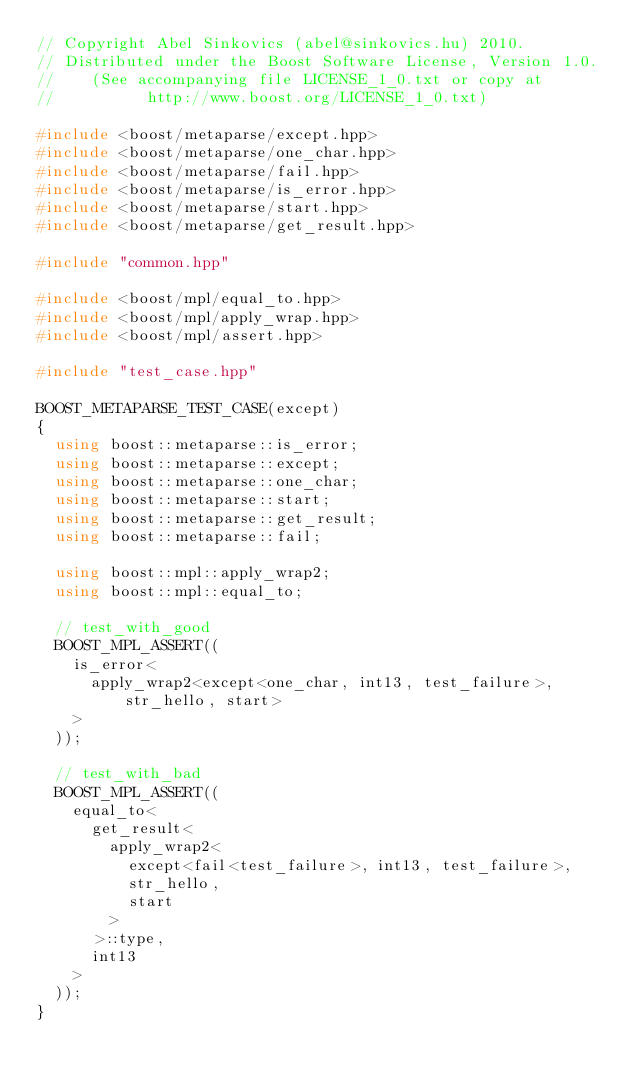Convert code to text. <code><loc_0><loc_0><loc_500><loc_500><_C++_>// Copyright Abel Sinkovics (abel@sinkovics.hu) 2010.
// Distributed under the Boost Software License, Version 1.0.
//    (See accompanying file LICENSE_1_0.txt or copy at
//          http://www.boost.org/LICENSE_1_0.txt)

#include <boost/metaparse/except.hpp>
#include <boost/metaparse/one_char.hpp>
#include <boost/metaparse/fail.hpp>
#include <boost/metaparse/is_error.hpp>
#include <boost/metaparse/start.hpp>
#include <boost/metaparse/get_result.hpp>

#include "common.hpp"

#include <boost/mpl/equal_to.hpp>
#include <boost/mpl/apply_wrap.hpp>
#include <boost/mpl/assert.hpp>

#include "test_case.hpp"

BOOST_METAPARSE_TEST_CASE(except)
{
  using boost::metaparse::is_error;
  using boost::metaparse::except;
  using boost::metaparse::one_char;
  using boost::metaparse::start;
  using boost::metaparse::get_result;
  using boost::metaparse::fail;
  
  using boost::mpl::apply_wrap2;
  using boost::mpl::equal_to;

  // test_with_good
  BOOST_MPL_ASSERT((
    is_error<
      apply_wrap2<except<one_char, int13, test_failure>, str_hello, start>
    >
  ));
  
  // test_with_bad
  BOOST_MPL_ASSERT((
    equal_to<
      get_result<
        apply_wrap2<
          except<fail<test_failure>, int13, test_failure>,
          str_hello,
          start
        >
      >::type,
      int13
    >
  ));
}



</code> 